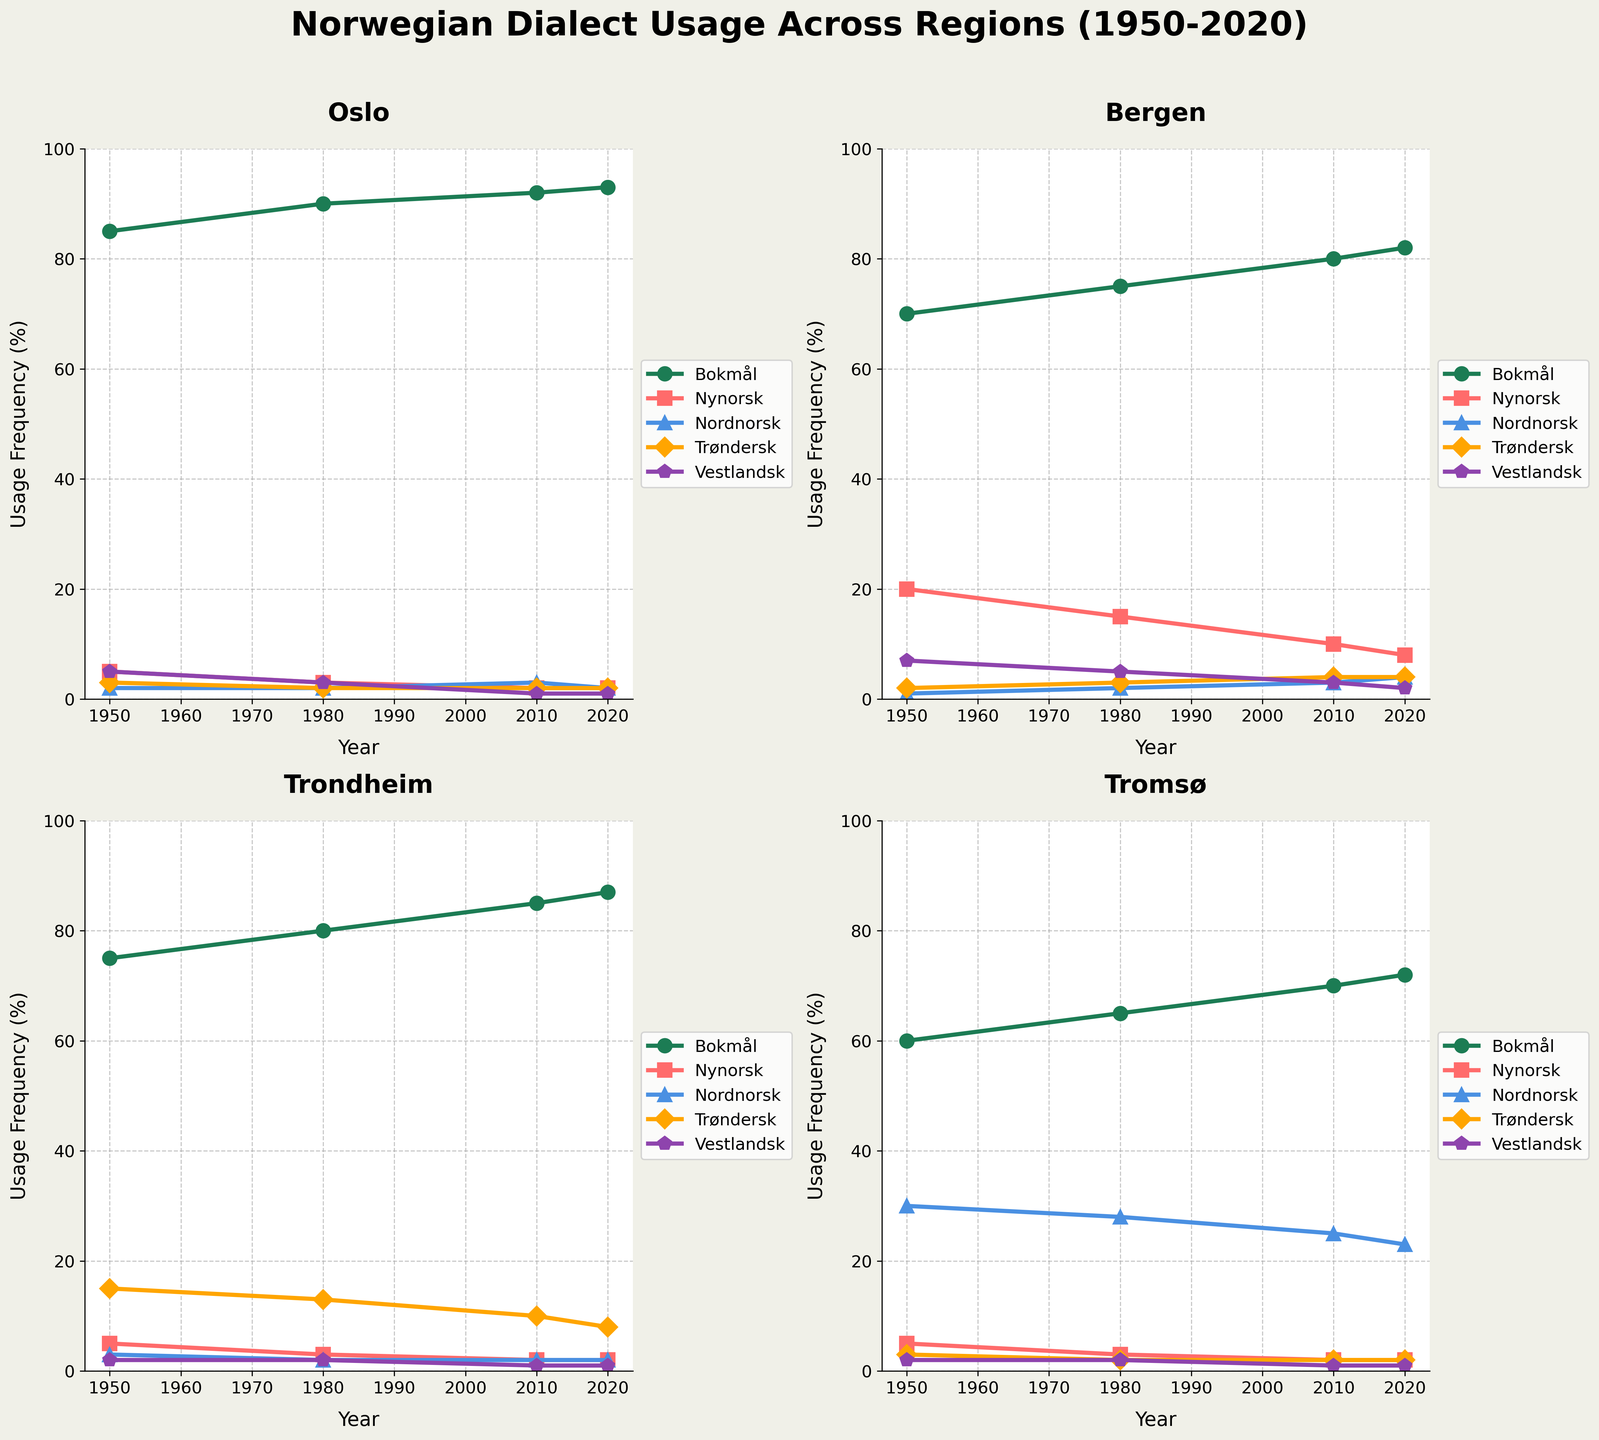What is the title of the combined plot? The title is usually found at the top of the plot. Reading it directly from the figure, we can see that it states "Norwegian Dialect Usage Across Regions (1950-2020)"
Answer: Norwegian Dialect Usage Across Regions (1950-2020) How has the usage of Bokmål changed in Oslo from 1950 to 2020? We need to trace the line representing Bokmål in the Oslo subplot. In 1950, Bokmål usage is at 85%, and in 2020, it is at 93%. This indicates an upward trend.
Answer: It increased from 85% to 93% Which dialect has the most stable usage in Bergen over the years? By examining each line in the Bergen subplot, we look for the line with the least fluctuation. Vestlandsk, oscillating minimally around 3-7%, seems the most stable.
Answer: Vestlandsk In 1980, which region had the highest usage of Nordnorsk? We need to compare the Nordnorsk values for all regions in 1980. Tromsø has the highest value at 28%, as seen in its subplot.
Answer: Tromsø What is the average usage of Nynorsk in Trondheim across all the years shown? First, sum the Nynorsk values for Trondheim for 1950 (5), 1980 (3), 2010 (2), and 2020 (2). The total is 12. Dividing by 4 (the number of points), the average is 3%.
Answer: 3% Did any dialects have a decreasing trend in Trondheim from 1950 to 2020? Tracing the lines in the Trondheim subplot, we see that Trøndersk dropped from 15% in 1950 to 8% in 2020, indicating a decreasing trend.
Answer: Trøndersk How does the usage frequency of Trøndersk in Tromsø compare between 1980 and 2010? We compare the 1980 value (2%) and the 2010 value (2%) for Trøndersk in the Tromsø subplot. Both values are the same.
Answer: It stayed the same Which region shows the highest increase in Bokmål usage from 1950 to 2020? We calculate the increase for each region: Oslo (93-85=8), Bergen (82-70=12), Trondheim (87-75=12), Tromsø (72-60=12). Bergen, Trondheim, and Tromsø all have an increase of 12%.
Answer: Bergen, Trondheim, Tromsø What is the difference in the usage of Nordnorsk between 1950 and 2020 in Tromsø? Subtract the 1950 value (30%) from the 2020 value (23%) for Nordnorsk in the Tromsø subplot. The difference is 30% - 23% = 7%.
Answer: 7% 